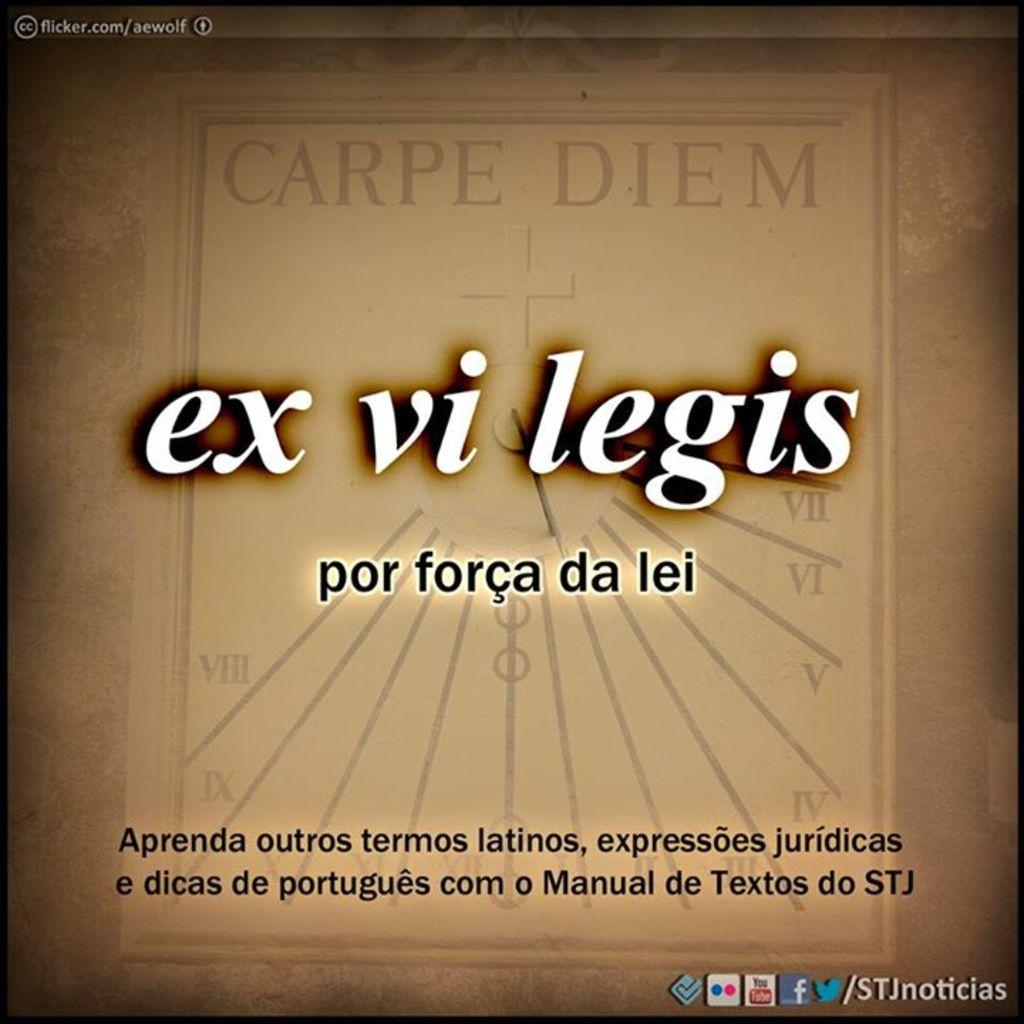<image>
Describe the image concisely. Advertisement that says "ex vi legis" in white and social media links on the bottom. 